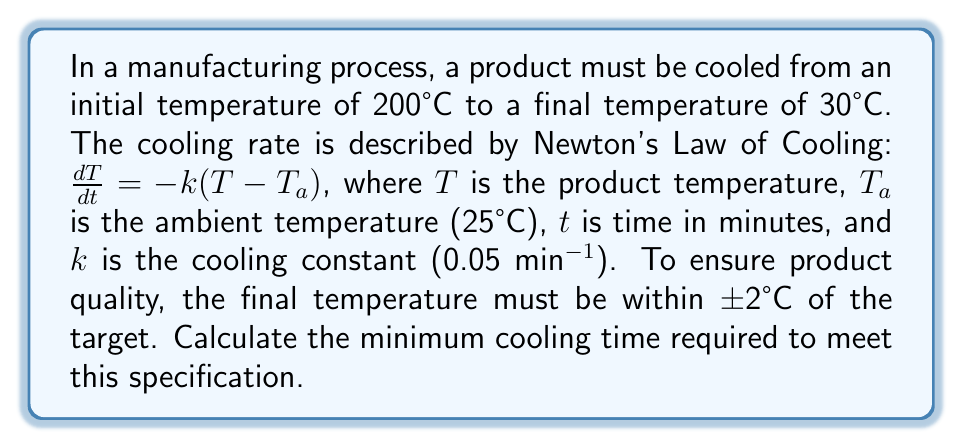Give your solution to this math problem. 1) We start with Newton's Law of Cooling in its integrated form:

   $$T(t) = T_a + (T_0 - T_a)e^{-kt}$$

   where $T(t)$ is the temperature at time $t$, $T_0$ is the initial temperature, and $T_a$ is the ambient temperature.

2) We're given:
   $T_0 = 200°C$
   $T_a = 25°C$
   $k = 0.05$ min^-1
   Final temperature range: $30°C ± 2°C$

3) To find the minimum cooling time, we need to solve for $t$ when $T(t) = 32°C$ (the upper limit of the acceptable range):

   $$32 = 25 + (200 - 25)e^{-0.05t}$$

4) Simplify:
   $$7 = 175e^{-0.05t}$$

5) Take natural log of both sides:
   $$\ln(7/175) = -0.05t$$

6) Solve for $t$:
   $$t = -\frac{\ln(7/175)}{0.05} = 64.62 \text{ minutes}$$

7) Round up to the nearest minute to ensure we're within the specified range:
   $t = 65 \text{ minutes}$
Answer: 65 minutes 